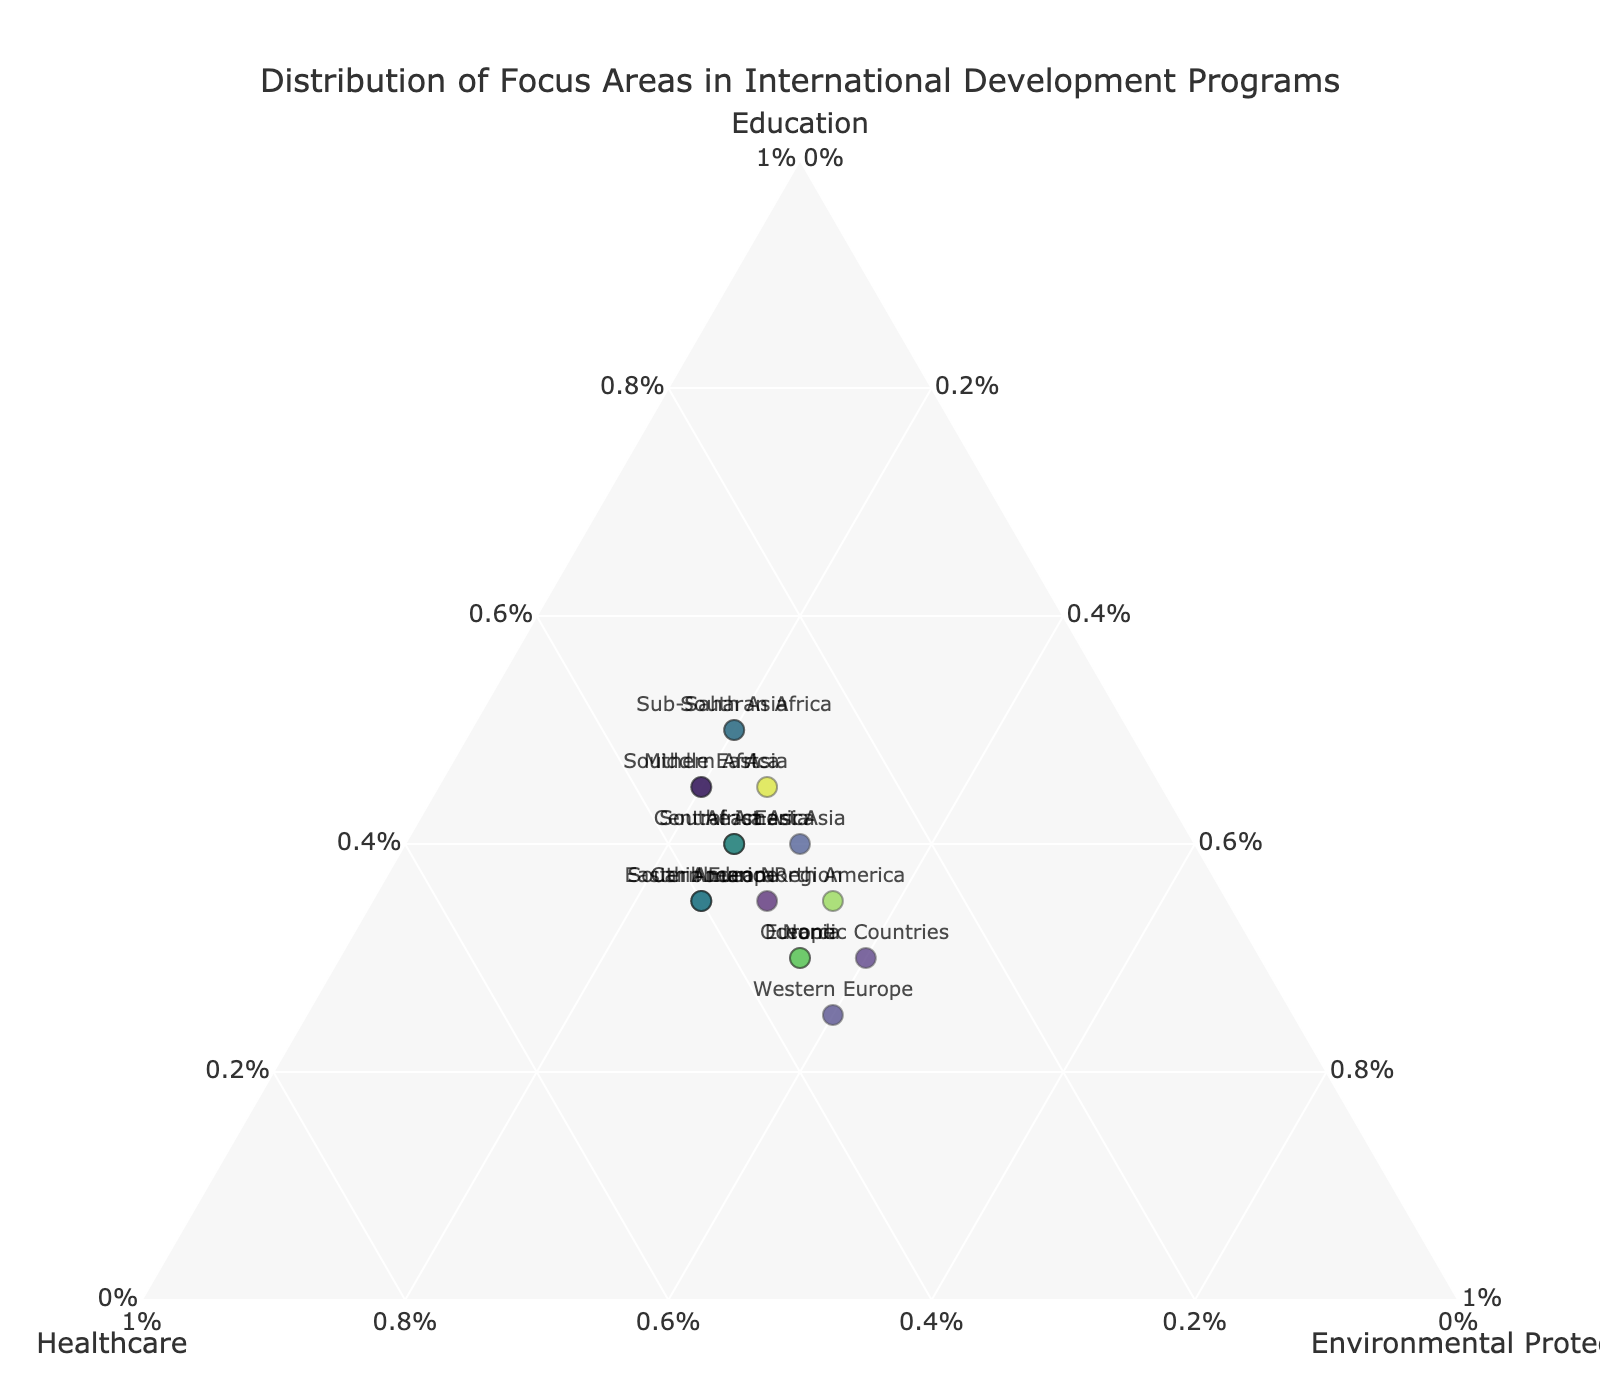Which continent has the highest focus on education? In the plot, the position closer to the 'Education' axis implies a higher percentage focus on education. By locating the data point closest to the 'Education' axis, we observe that 'South Asia' has the highest percentage focus on education, marked at 50%.
Answer: South Asia Which continent balances education, healthcare, and environmental protection equally (or nearly equally)? To find an equal balance, identify the data point that approximates equal percentages on all three axes (around 33% each). 'Andean Region' has the distribution (35%, 35%, 30%) which is close to equal balance among the three focus areas.
Answer: Andean Region How does the focus on healthcare differ between South America and Europe? For South America, the healthcare focus is 40%. For Europe, it is 35%. By subtracting these values, we find the difference: 40% - 35% = 5%. Therefore, South America has a 5% higher focus on healthcare compared to Europe.
Answer: 5% Which region places the least focus on environmental protection and what is that percentage? The region closest to the 'Environmental Protection' axis with the least value will represent the lowest focus. By checking the percentages, both 'Sub-Saharan Africa' and 'South Asia' have the lowest focus on environmental protection at 20%.
Answer: Sub-Saharan Africa and South Asia, 20% Which continent has the highest percentage focus on environmental protection, and by how much is it higher than the focus of Middle East on the same area? The highest focus on environmental protection is from 'Western Europe' and 'Nordic Countries,' both with 40%. The Middle East has a focus of 20%. So, by the mathematical difference: 40% - 20% = 20%.
Answer: Western Europe and Nordic Countries, 20% Is there any continent that has an equal focus on education and healthcare? Identifying the data points where the percentages for 'Education' and 'Healthcare' are the same reveals 'Southern Africa' with 45% focus on both education and healthcare.
Answer: Southern Africa How do the focuses on the three areas in North America compare? North America's distribution is 35% on Education, 30% on Healthcare, and 35% on Environmental Protection. The percentages for education and environmental protection are equal, and both are higher than healthcare by 5%.
Answer: Education: 35%, Healthcare: 30%, Environmental Protection: 35% Which continent shows a higher variance in focus areas: Africa or Asia? Variance is calculated as the average of the squared differences from the mean. For Africa: Mean focus = (40 + 35 + 25)/3 = 33.33. Variances: (40-33.33)^2 + (35-33.33)^2 + (25-33.33)^2 = 44.44+2.78+69.44 = 116.66/3 = 38.89. For Asia: Mean focus = (45 + 30 + 25)/3 = 33.33. Variances: (45-33.33)^2 + (30-33.33)^2 + (25-33.33)^2 = 138.89 + 11.11 + 69.44 = 219.44/3 = 73.15. Asia has a higher variance of 73.15 compared to Africa's 38.89.
Answer: Asia What is the average focus on healthcare across all continents? Summing the healthcare focus values for all regions and dividing by the number of regions gives: (35+30+35+30+40+35+30+35+40+35+35+40+30+30+35+30+35+35) / 18 = 650 / 18 ≈ 36.11%.
Answer: 36.11% 